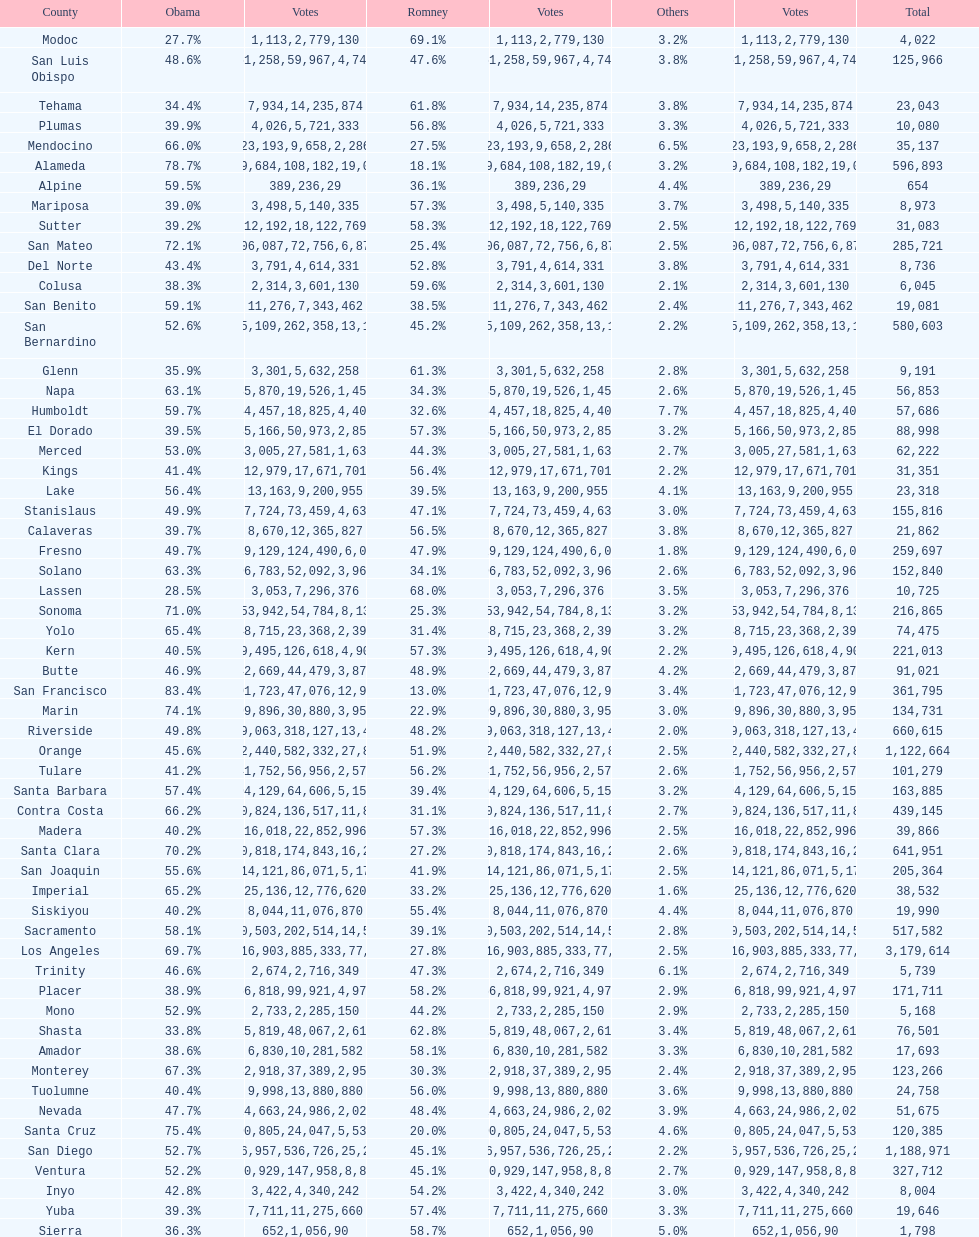Did romney earn more or less votes than obama did in alameda county? Less. 